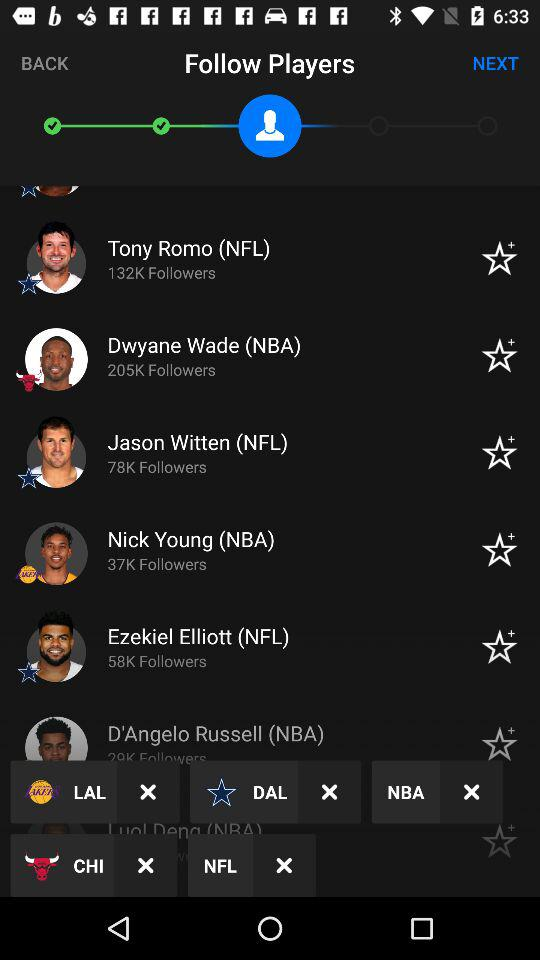How many followers does Tony Romo have? Tony Romo has 132K followers. 